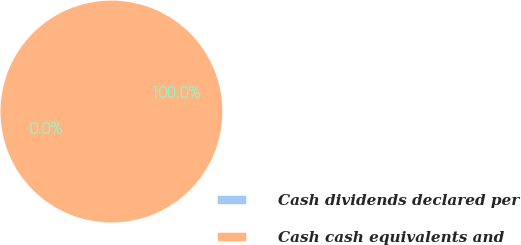Convert chart to OTSL. <chart><loc_0><loc_0><loc_500><loc_500><pie_chart><fcel>Cash dividends declared per<fcel>Cash cash equivalents and<nl><fcel>0.0%<fcel>100.0%<nl></chart> 